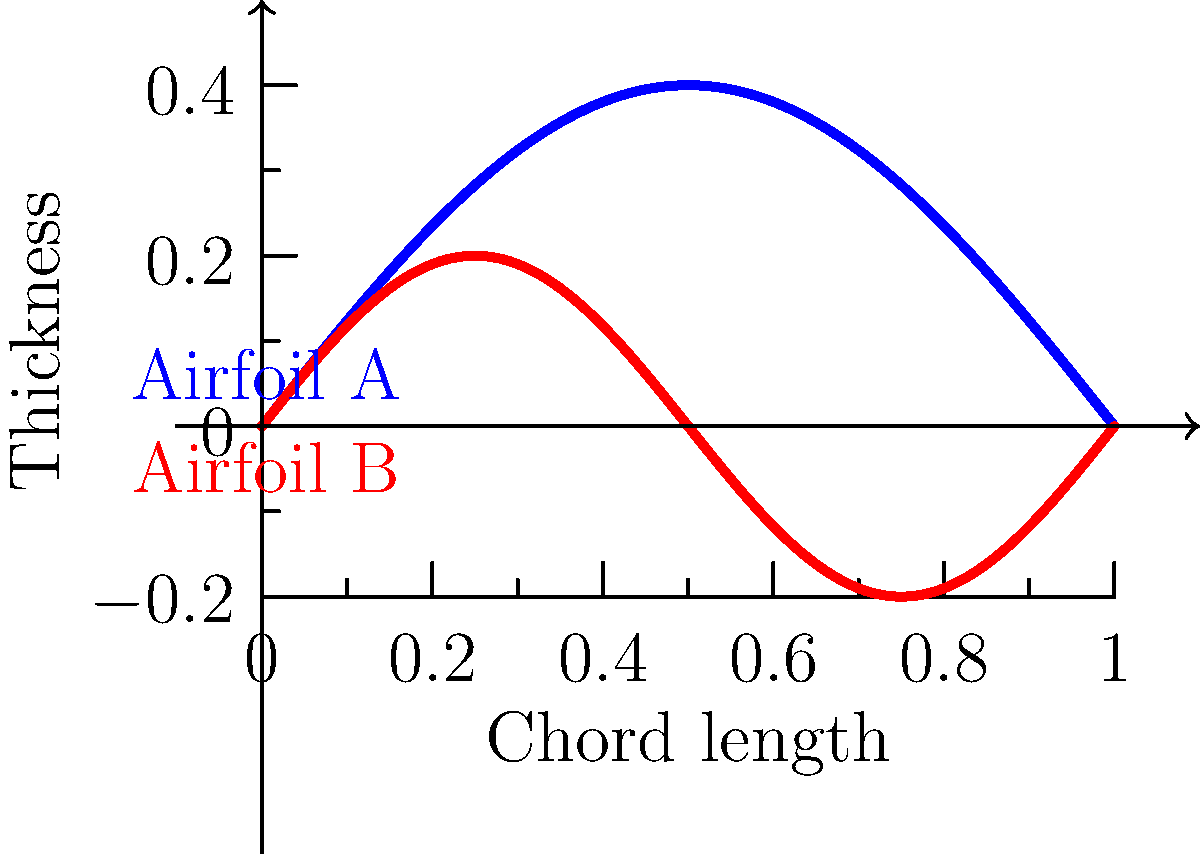As a filmmaker interested in the physics behind aerial cinematography, you're researching airfoil designs for a documentary on cutting-edge drone technology. Given the flow patterns around two different airfoil shapes shown in the graph, which airfoil would likely generate more lift at lower speeds, making it suitable for stable, slow-motion aerial shots? To answer this question, we need to analyze the airfoil shapes and their implications for lift generation:

1. Airfoil A (blue curve):
   - Has a larger maximum thickness
   - Has a more pronounced camber (curvature)
   - The maximum camber occurs near the middle of the chord length

2. Airfoil B (red curve):
   - Has a smaller maximum thickness
   - Has less pronounced camber
   - The camber line oscillates more frequently

3. Lift generation factors:
   - Camber contributes significantly to lift production
   - A larger maximum thickness can create a greater pressure difference between upper and lower surfaces
   - The position of maximum camber affects the distribution of lift along the chord

4. Low-speed considerations:
   - At lower speeds, a more pronounced camber helps in maintaining lift
   - A thicker airfoil generally performs better at lower speeds due to improved boundary layer characteristics

5. Stability for cinematography:
   - A more gradual and pronounced camber (as in Airfoil A) typically provides more stable lift characteristics, which is beneficial for smooth aerial footage

Conclusion: Airfoil A, with its larger camber and thickness, would likely generate more lift at lower speeds. This makes it more suitable for stable, slow-motion aerial shots in drone cinematography.
Answer: Airfoil A 